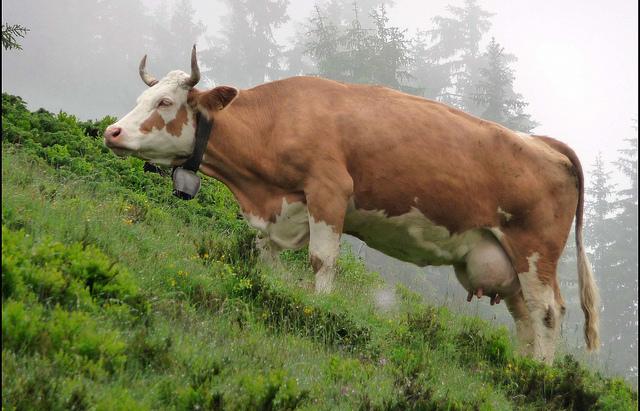Is it daytime?
Short answer required. Yes. How many cows are in the scene?
Quick response, please. 1. Does the cow have horns?
Keep it brief. Yes. What is around the cows neck?
Short answer required. Bell. What color is this cow?
Concise answer only. Brown and white. What part of the animal is the darkest brown?
Answer briefly. Back. 